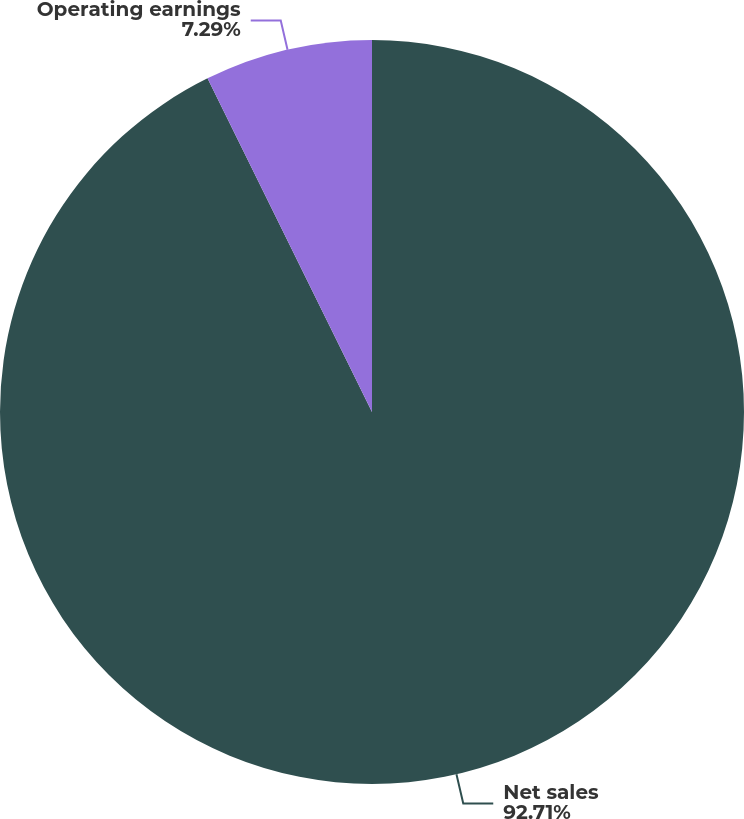Convert chart. <chart><loc_0><loc_0><loc_500><loc_500><pie_chart><fcel>Net sales<fcel>Operating earnings<nl><fcel>92.71%<fcel>7.29%<nl></chart> 